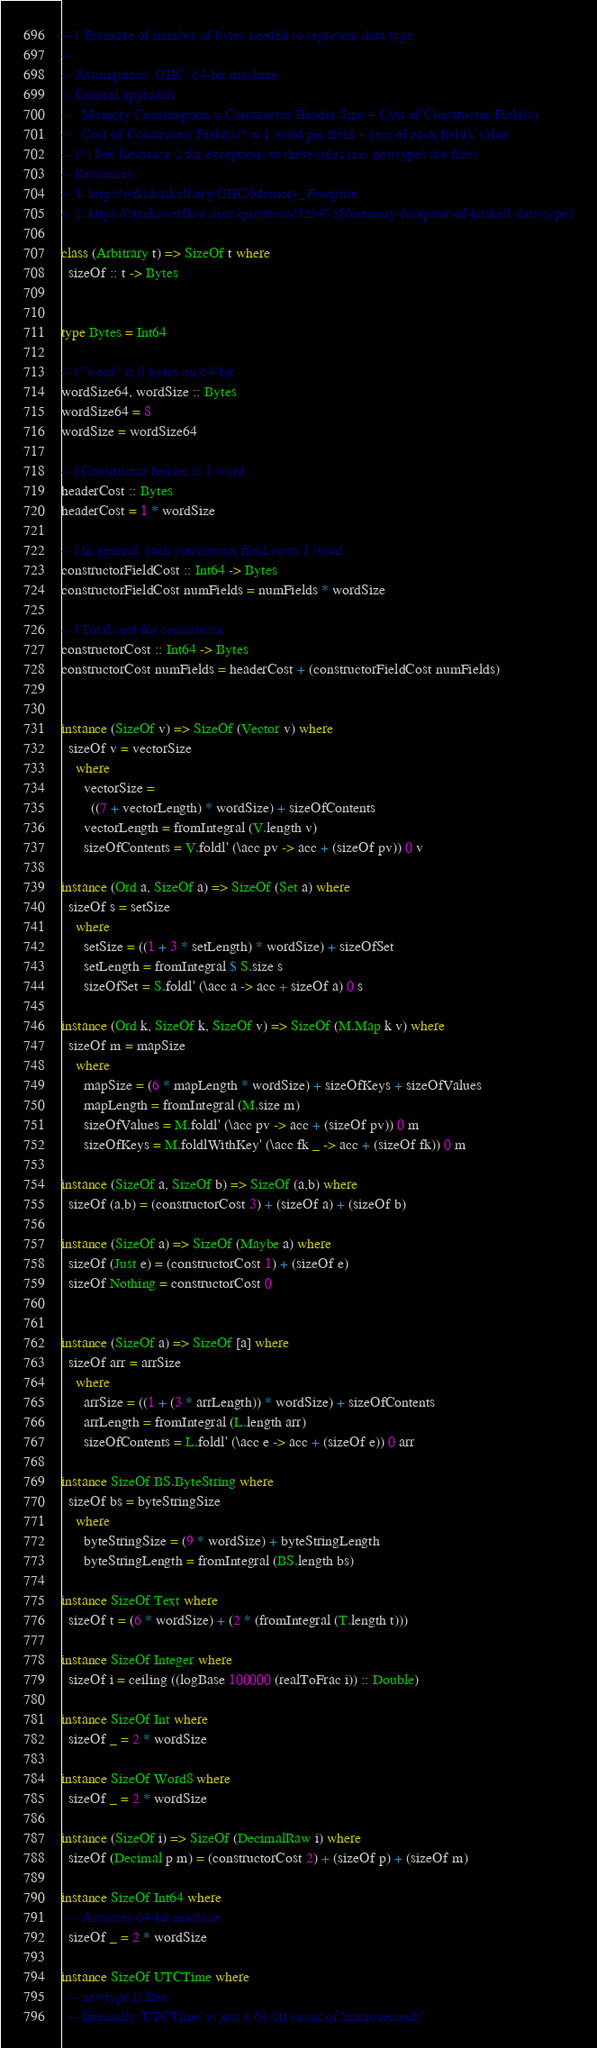Convert code to text. <code><loc_0><loc_0><loc_500><loc_500><_Haskell_>-- |  Estimate of number of bytes needed to represent data type
--
-- Assumptions: GHC, 64-bit machine
-- General approach:
--   Memory Consumption = Constructor Header Size + Cost of Constructor Field(s)
--   Cost of Constructor Field(s)* = 1 word per field + cost of each field's value
-- (*) See Resource 2 for exceptions to these rules (i.e. newtypes are free)
-- Resources:
-- 1. http://wiki.haskell.org/GHC/Memory_Footprint
-- 2. https://stackoverflow.com/questions/3254758/memory-footprint-of-haskell-data-types

class (Arbitrary t) => SizeOf t where
  sizeOf :: t -> Bytes


type Bytes = Int64

-- | "word" is 8 bytes on 64-bit
wordSize64, wordSize :: Bytes
wordSize64 = 8
wordSize = wordSize64

-- | Constructor header is 1 word
headerCost :: Bytes
headerCost = 1 * wordSize

-- | In general, each constructor field costs 1 word
constructorFieldCost :: Int64 -> Bytes
constructorFieldCost numFields = numFields * wordSize

-- | Total cost for constructor
constructorCost :: Int64 -> Bytes
constructorCost numFields = headerCost + (constructorFieldCost numFields)


instance (SizeOf v) => SizeOf (Vector v) where
  sizeOf v = vectorSize
    where
      vectorSize =
        ((7 + vectorLength) * wordSize) + sizeOfContents
      vectorLength = fromIntegral (V.length v)
      sizeOfContents = V.foldl' (\acc pv -> acc + (sizeOf pv)) 0 v

instance (Ord a, SizeOf a) => SizeOf (Set a) where
  sizeOf s = setSize
    where
      setSize = ((1 + 3 * setLength) * wordSize) + sizeOfSet
      setLength = fromIntegral $ S.size s
      sizeOfSet = S.foldl' (\acc a -> acc + sizeOf a) 0 s

instance (Ord k, SizeOf k, SizeOf v) => SizeOf (M.Map k v) where
  sizeOf m = mapSize
    where
      mapSize = (6 * mapLength * wordSize) + sizeOfKeys + sizeOfValues
      mapLength = fromIntegral (M.size m)
      sizeOfValues = M.foldl' (\acc pv -> acc + (sizeOf pv)) 0 m
      sizeOfKeys = M.foldlWithKey' (\acc fk _ -> acc + (sizeOf fk)) 0 m

instance (SizeOf a, SizeOf b) => SizeOf (a,b) where
  sizeOf (a,b) = (constructorCost 3) + (sizeOf a) + (sizeOf b)

instance (SizeOf a) => SizeOf (Maybe a) where
  sizeOf (Just e) = (constructorCost 1) + (sizeOf e)
  sizeOf Nothing = constructorCost 0


instance (SizeOf a) => SizeOf [a] where
  sizeOf arr = arrSize
    where
      arrSize = ((1 + (3 * arrLength)) * wordSize) + sizeOfContents
      arrLength = fromIntegral (L.length arr)
      sizeOfContents = L.foldl' (\acc e -> acc + (sizeOf e)) 0 arr

instance SizeOf BS.ByteString where
  sizeOf bs = byteStringSize
    where
      byteStringSize = (9 * wordSize) + byteStringLength
      byteStringLength = fromIntegral (BS.length bs)

instance SizeOf Text where
  sizeOf t = (6 * wordSize) + (2 * (fromIntegral (T.length t)))

instance SizeOf Integer where
  sizeOf i = ceiling ((logBase 100000 (realToFrac i)) :: Double)

instance SizeOf Int where
  sizeOf _ = 2 * wordSize

instance SizeOf Word8 where
  sizeOf _ = 2 * wordSize

instance (SizeOf i) => SizeOf (DecimalRaw i) where
  sizeOf (Decimal p m) = (constructorCost 2) + (sizeOf p) + (sizeOf m)

instance SizeOf Int64 where
  -- Assumes 64-bit machine
  sizeOf _ = 2 * wordSize

instance SizeOf UTCTime where
  -- newtype is free
  -- Internally 'UTCTime' is just a 64-bit count of 'microseconds'</code> 